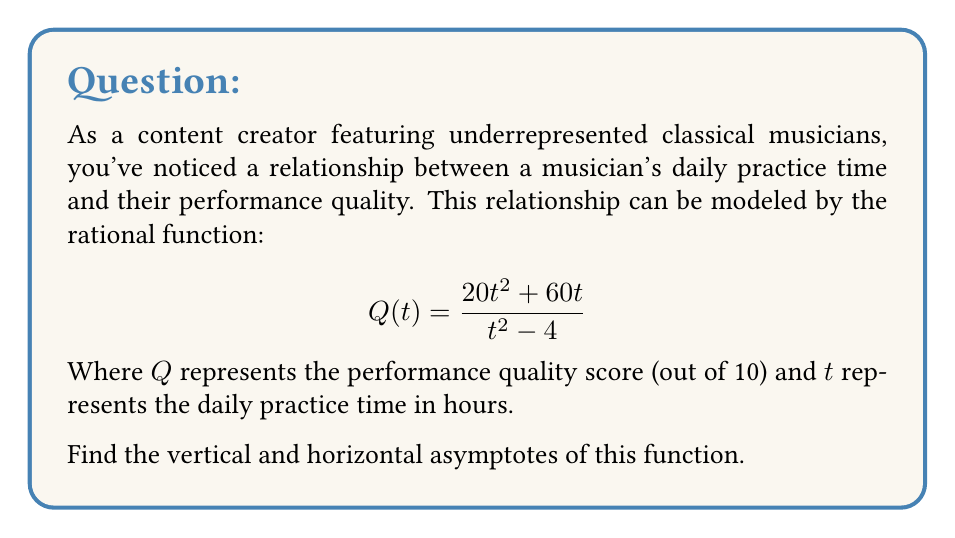What is the answer to this math problem? To find the asymptotes of this rational function, we'll follow these steps:

1. Vertical asymptotes:
   Vertical asymptotes occur when the denominator equals zero.
   Set $t^2 - 4 = 0$
   $t^2 = 4$
   $t = \pm 2$
   So, vertical asymptotes occur at $t = 2$ and $t = -2$

2. Horizontal asymptote:
   To find the horizontal asymptote, we compare the degrees of the numerator and denominator.
   Degree of numerator: 2
   Degree of denominator: 2
   
   When degrees are equal, the horizontal asymptote is the ratio of the leading coefficients.
   Leading coefficient of numerator: 20
   Leading coefficient of denominator: 1
   
   Horizontal asymptote: $y = \frac{20}{1} = 20$

3. Interpretation:
   - The vertical asymptotes at $t = \pm 2$ suggest that as practice time approaches 2 hours (positive or negative), the performance quality approaches infinity. (Note: negative time is not realistic in this context)
   - The horizontal asymptote at $y = 20$ indicates that as practice time increases indefinitely, the performance quality score approaches 20 (which exceeds the maximum score of 10, indicating a limitation of this model for very large values of t)
Answer: Vertical asymptotes: $t = 2$ and $t = -2$
Horizontal asymptote: $y = 20$ 